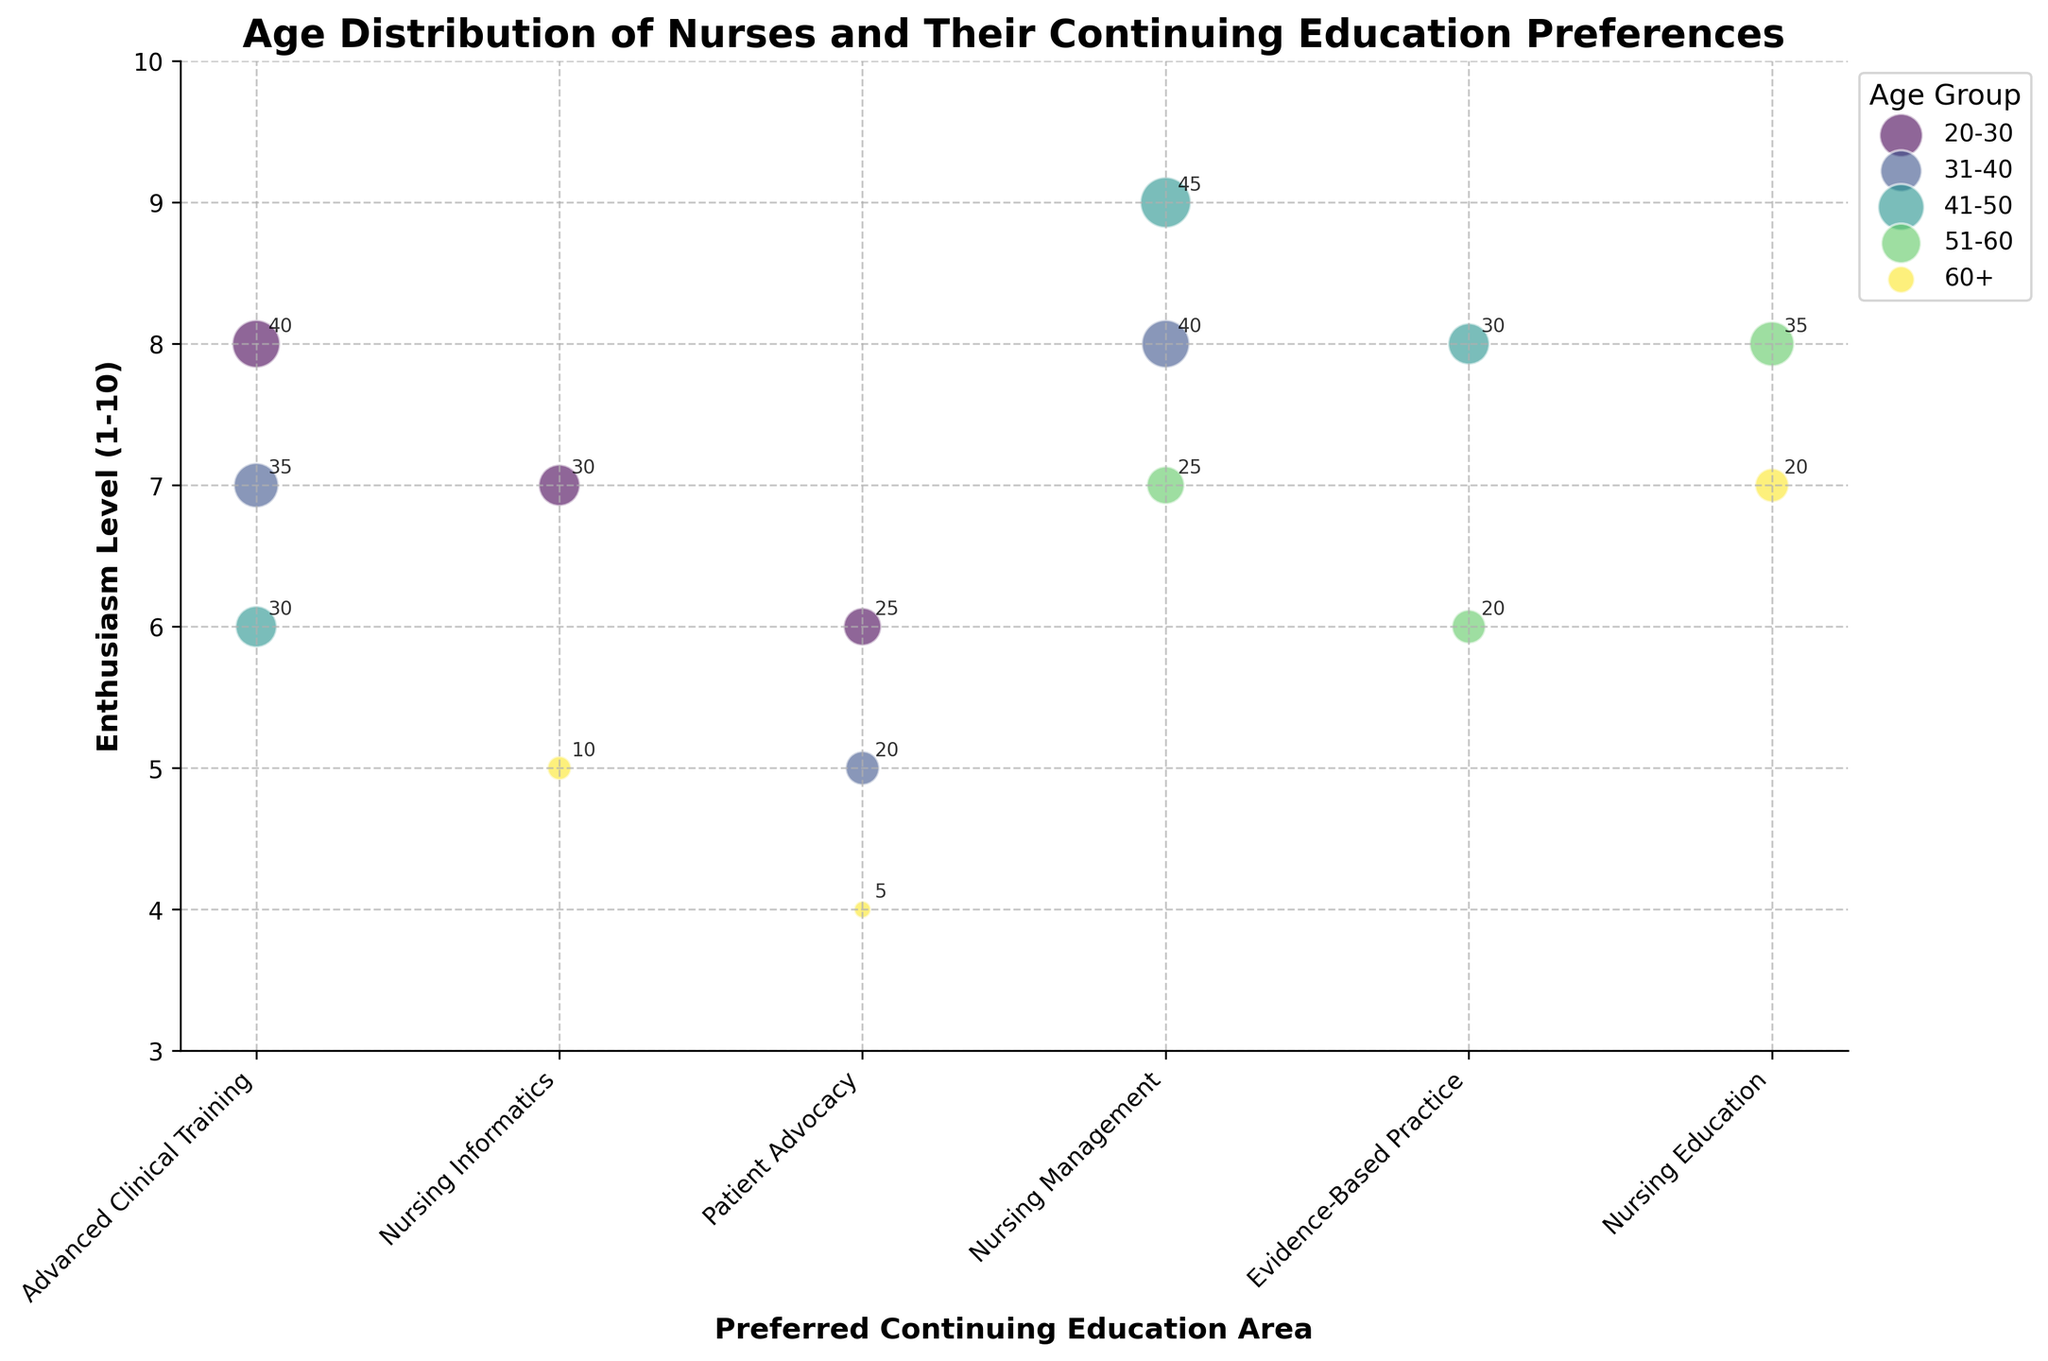What is the title of the figure? The title is located at the top of the figure and states what the chart is about. The title helps us understand the purpose and main theme of the chart.
Answer: Age Distribution of Nurses and Their Continuing Education Preferences Which age group has the highest enthusiasm level for Nursing Management? Look for the bubbles in the 'Nursing Management' column and identify the highest 'Enthusiasm Level' among them, then refer to the age group label in the legend.
Answer: 41-50 What is the preferred continuing education area for nurses aged 51-60? Identify the bubbles primarily associated with the '51-60' age group, then observe which education area these bubbles are located in.
Answer: Nursing Management What is the number of nurses aged 20-30 who prefer Nursing Informatics? Find the bubble corresponding to 'Nursing Informatics' in the '20-30' age group and look at the number inside or near the bubble.
Answer: 30 How does the enthusiasm level for Evidence-Based Practice change across age groups? Observe the 'Evidence-Based Practice' bubbles and note the enthusiasm levels for each age group sequentially.
Answer: 41-50 has an enthusiasm level of 8, 51-60 has 6. The 20-30 and 31-40 age groups do not have data points for Evidence-Based Practice Which age group has the smallest number of nurses interested in Patient Advocacy, and what is the number of nurses? Look at all the bubbles in the 'Patient Advocacy' column and identify the smallest number, then refer to the age group label.
Answer: 60+, 5 What is the average enthusiasm level for nurses in the 20-30 age group? Add the enthusiasm levels (8+7+6) and divide by the number of categories (3) for the 20-30 age group.
Answer: 7 Is there an age group that shows interest in every listed continuing education area? Examine each column (continuing education area) and see if any age group has a corresponding bubble in each column.
Answer: No Which preferred continuing education area has the largest bubble, and what does it represent? Look for the biggest bubble on the chart, note its preferred continuing education area and the number inside or near it.
Answer: Nursing Management, 45 nurses 